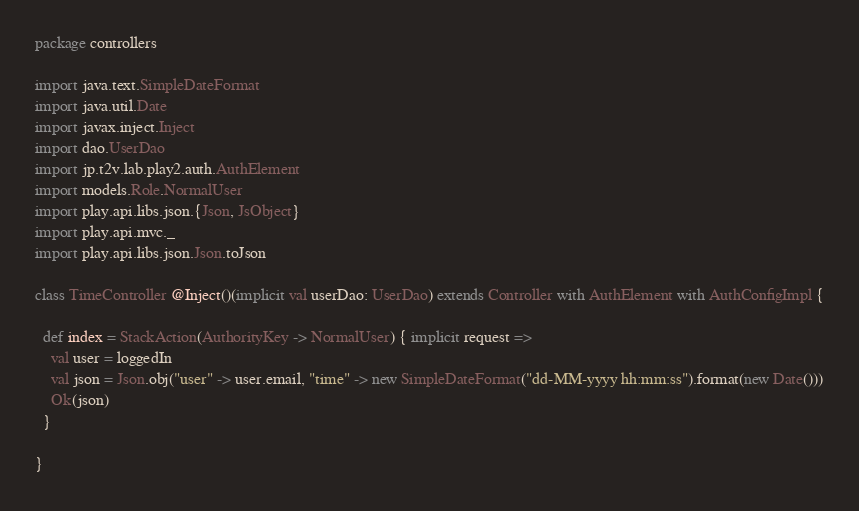Convert code to text. <code><loc_0><loc_0><loc_500><loc_500><_Scala_>package controllers

import java.text.SimpleDateFormat
import java.util.Date
import javax.inject.Inject
import dao.UserDao
import jp.t2v.lab.play2.auth.AuthElement
import models.Role.NormalUser
import play.api.libs.json.{Json, JsObject}
import play.api.mvc._
import play.api.libs.json.Json.toJson

class TimeController @Inject()(implicit val userDao: UserDao) extends Controller with AuthElement with AuthConfigImpl {

  def index = StackAction(AuthorityKey -> NormalUser) { implicit request =>
    val user = loggedIn
    val json = Json.obj("user" -> user.email, "time" -> new SimpleDateFormat("dd-MM-yyyy hh:mm:ss").format(new Date()))
    Ok(json)
  }

}
</code> 